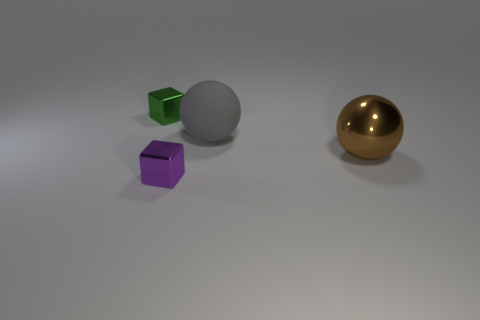Are there any other things that have the same material as the large gray object?
Ensure brevity in your answer.  No. Are there the same number of small purple objects behind the brown sphere and large metallic blocks?
Your response must be concise. Yes. What is the shape of the large object that is made of the same material as the purple block?
Make the answer very short. Sphere. How many rubber objects are either big brown objects or small yellow things?
Keep it short and to the point. 0. How many tiny green shiny blocks are in front of the ball in front of the matte sphere?
Your answer should be compact. 0. How many green things have the same material as the purple thing?
Provide a short and direct response. 1. What number of small things are gray rubber things or spheres?
Offer a terse response. 0. What is the shape of the object that is on the right side of the tiny purple metal thing and in front of the large rubber object?
Offer a very short reply. Sphere. Does the brown sphere have the same material as the small purple thing?
Make the answer very short. Yes. What color is the other ball that is the same size as the gray rubber ball?
Your response must be concise. Brown. 